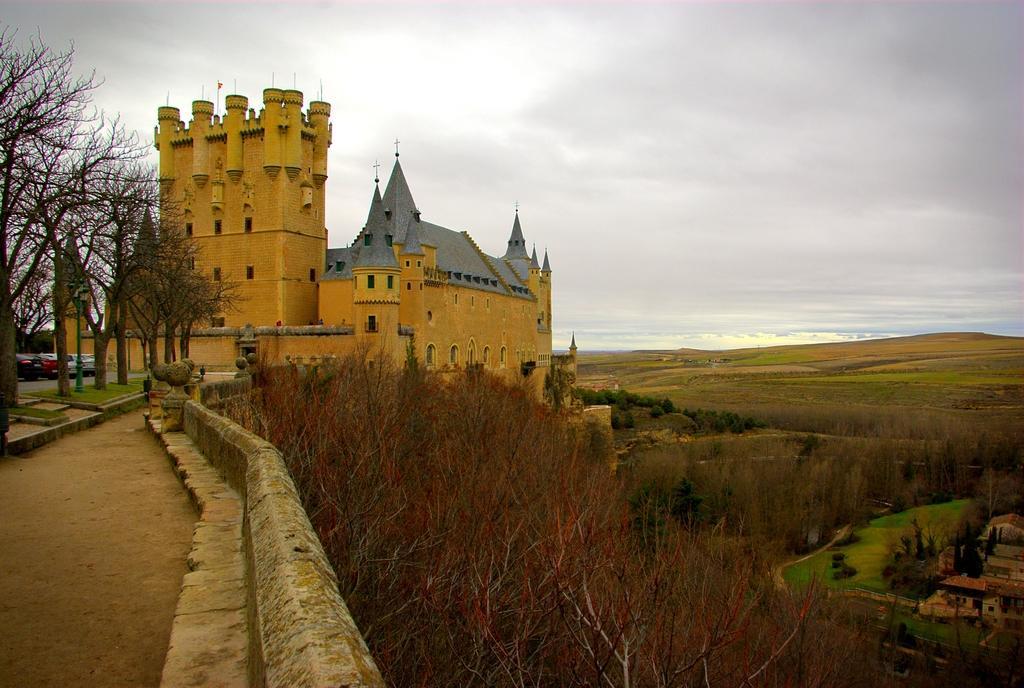How would you summarize this image in a sentence or two? In this picture I can see few trees, cars on the left side. In the middle there is a building, at the top there is the sky. 